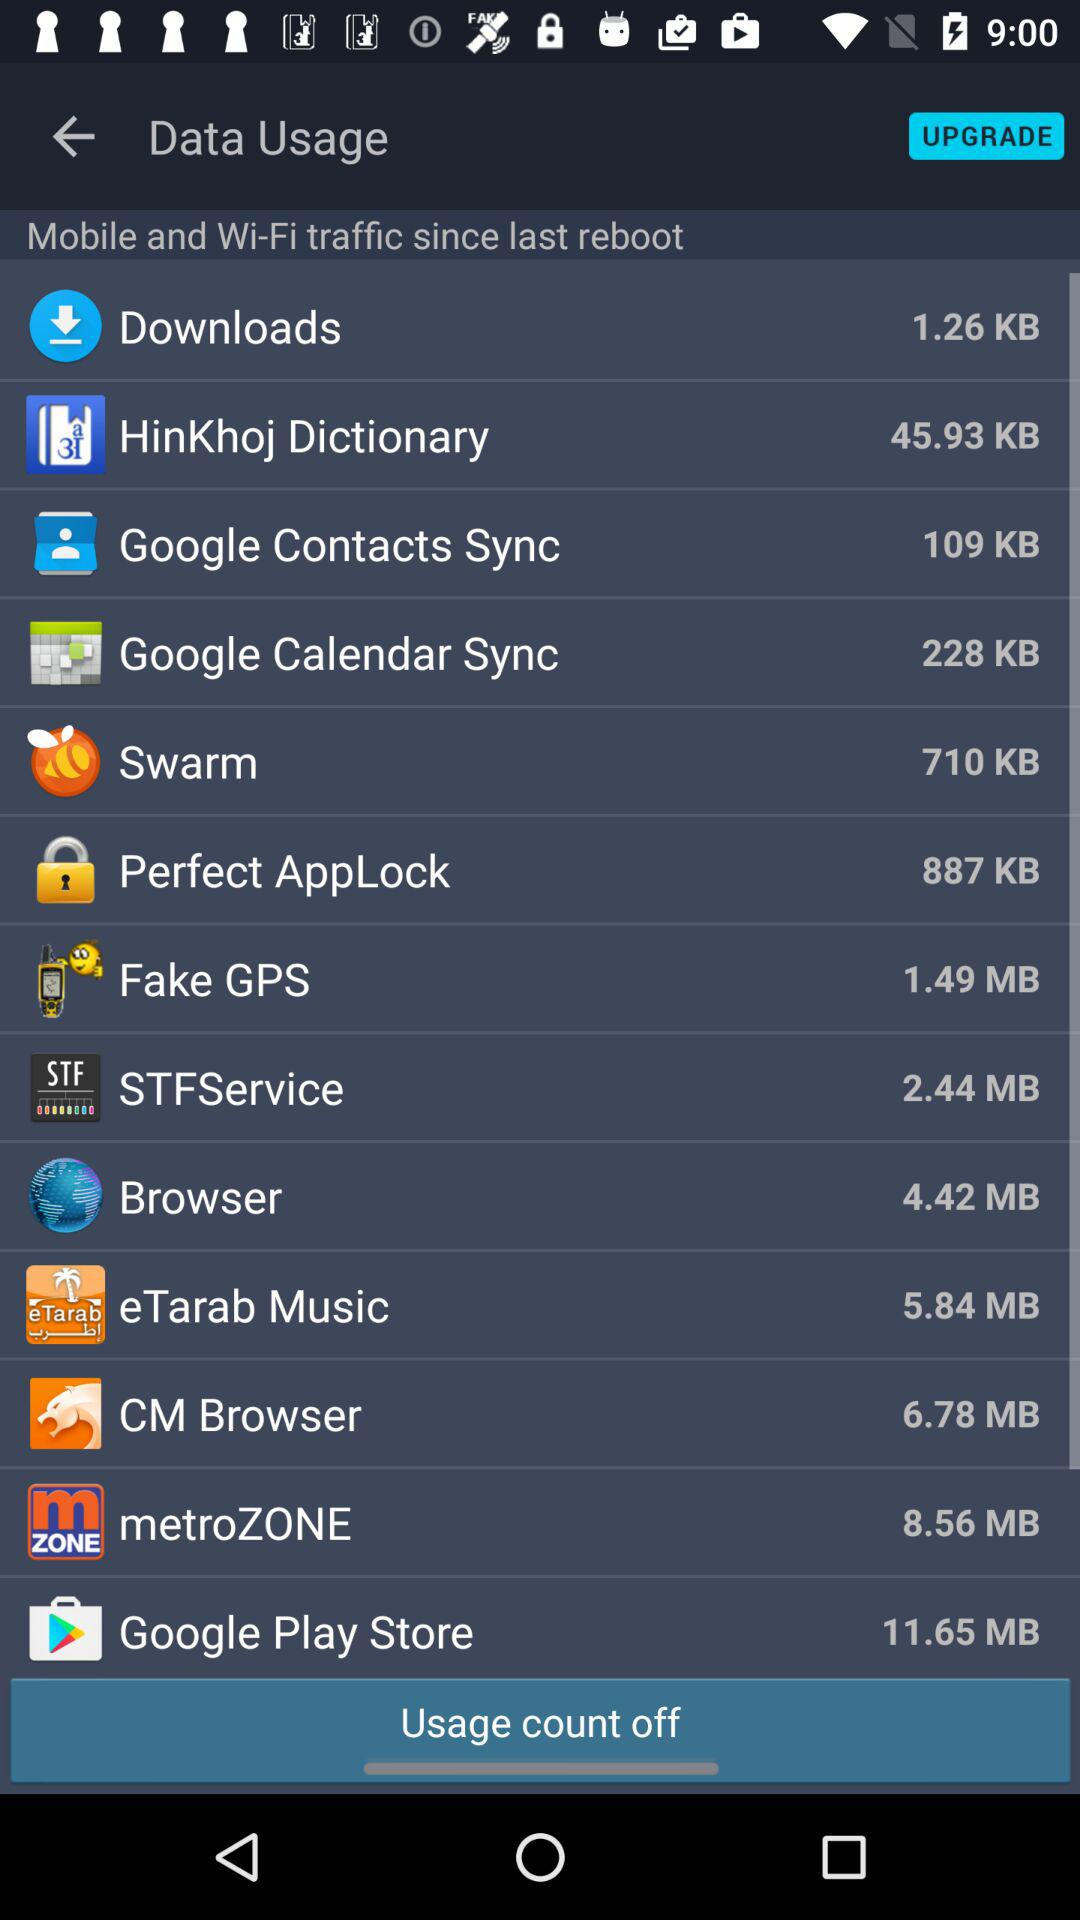What's the data usage size of the "Fake GPS" application? The data usage size of the "Fake GPS" application is 1.49 MB. 